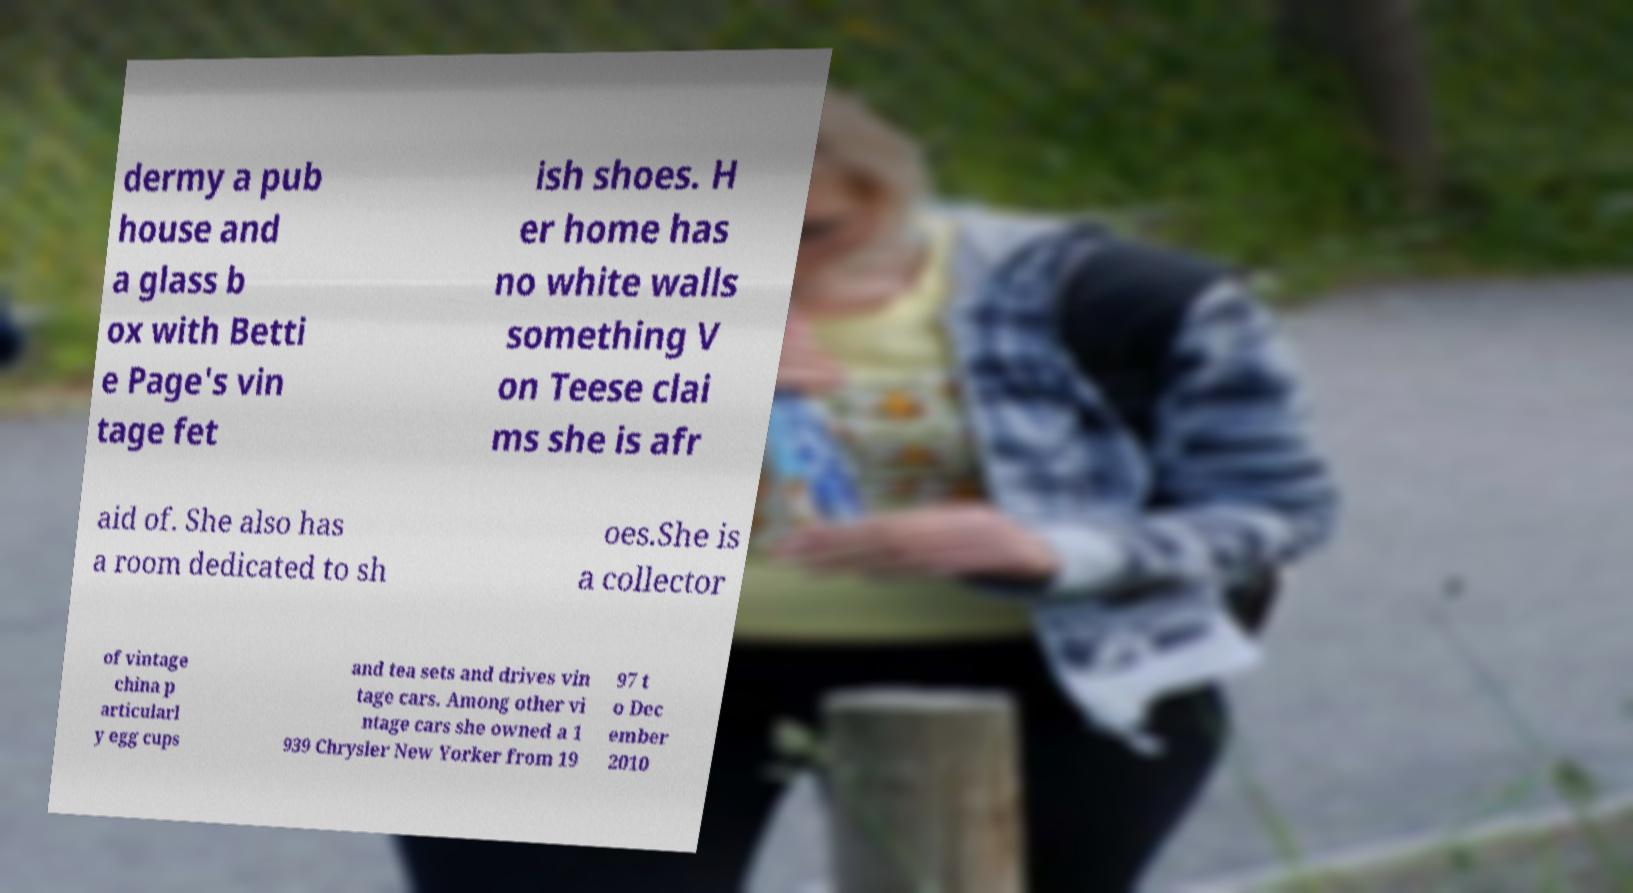Can you read and provide the text displayed in the image?This photo seems to have some interesting text. Can you extract and type it out for me? dermy a pub house and a glass b ox with Betti e Page's vin tage fet ish shoes. H er home has no white walls something V on Teese clai ms she is afr aid of. She also has a room dedicated to sh oes.She is a collector of vintage china p articularl y egg cups and tea sets and drives vin tage cars. Among other vi ntage cars she owned a 1 939 Chrysler New Yorker from 19 97 t o Dec ember 2010 